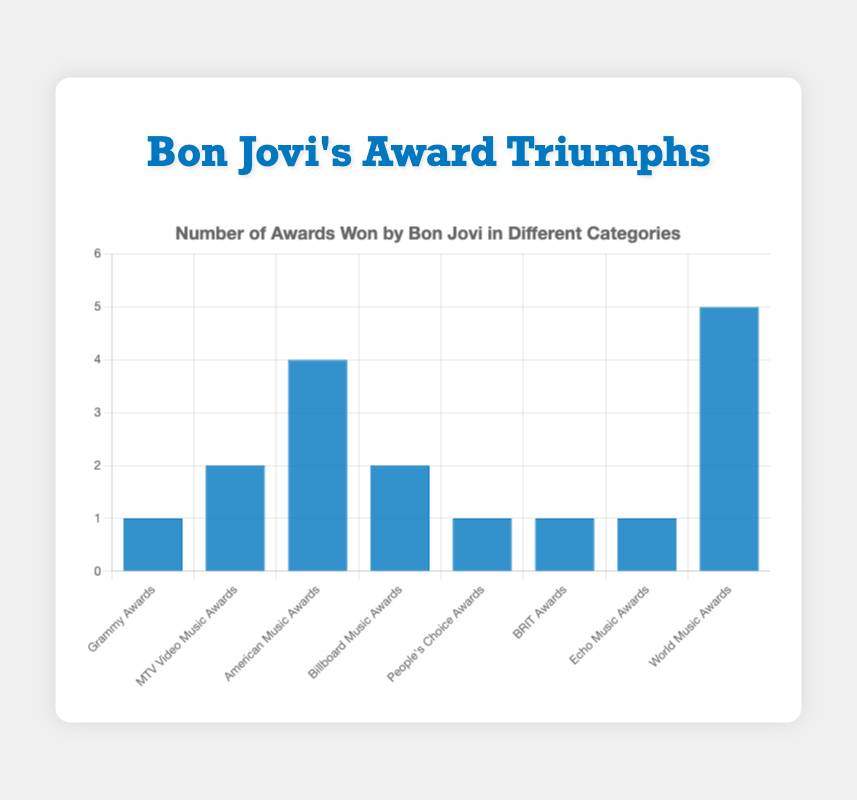Which award category has the highest number of awards? The "World Music Awards" bar is the tallest, indicating that Bon Jovi has won the most awards in this category.
Answer: World Music Awards Which two categories have the same number of awards? Both "Grammy Awards" and "People's Choice Awards" have bars of equal height, each representing 1 award. Similarly, "MTV Video Music Awards" and "Billboard Music Awards" both have 2 awards.
Answer: Grammy Awards, People's Choice Awards and MTV Video Music Awards, Billboard Music Awards How many more awards has Bon Jovi won in "World Music Awards" compared to "Grammy Awards"? The number of awards in "World Music Awards" is 5, and in "Grammy Awards" is 1. The difference is 5 - 1 = 4.
Answer: 4 What is the total number of awards Bon Jovi has won across all categories? Add the number of awards in each category: 1 (Grammy) + 2 (MTV Video Music Awards) + 4 (American Music Awards) + 2 (Billboard) + 1 (People's Choice) + 1 (BRIT) + 1 (Echo Music) + 5 (World Music) = 17.
Answer: 17 Which bar is blue and represents the number of awards won in the "Billboard Music Awards" category? The fourth bar from left to right is blue and represents the "Billboard Music Awards" category, with a count of 2.
Answer: Billboard Music Awards Does Bon Jovi have more "American Music Awards" or "MTV Video Music Awards"? "American Music Awards" bar height is greater than "MTV Video Music Awards" bar height, indicating more awards.
Answer: American Music Awards What is the average number of awards won by Bon Jovi per category? Sum the total number of awards and divide by the number of categories: 17 awards / 8 categories = 2.125.
Answer: 2.125 How many awards has Bon Jovi won in categories with exactly 1 award each? Categories with exactly 1 award are: "Grammy Awards," "People's Choice Awards," "BRIT Awards," and "Echo Music Awards." Total: 1 + 1 + 1 + 1 = 4.
Answer: 4 What is the difference in the number of awards between the category with the most awards and the one with the fewest awards? The highest number of awards is 5 (World Music Awards) and the lowest is 1 (several categories). The difference is 5 - 1 = 4.
Answer: 4 